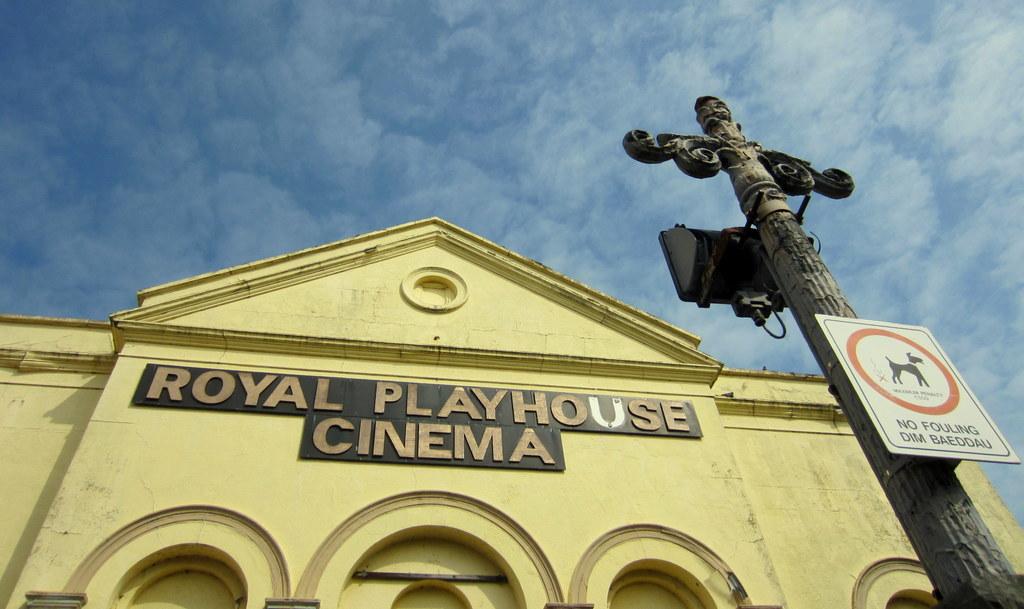What is inside the cinema?
Offer a very short reply. Royal playhouse. What is the name of this cinema?
Provide a succinct answer. Royal playhouse. 